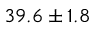<formula> <loc_0><loc_0><loc_500><loc_500>3 9 . 6 \pm { 1 . 8 }</formula> 